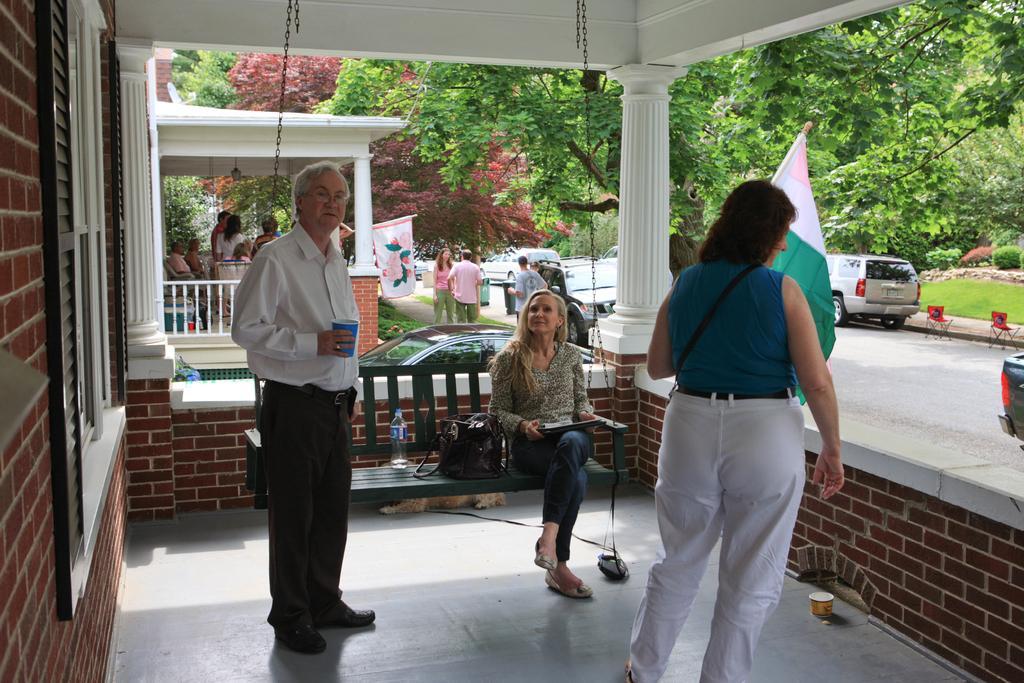How would you summarize this image in a sentence or two? In this picture I can observe three members in the middle of the picture. One of them is a man. Two of them are women. On the right side I can observe flag and two cars parked on the road. In the background there are some people and I can observe some trees. 